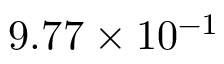Convert formula to latex. <formula><loc_0><loc_0><loc_500><loc_500>9 . 7 7 \times 1 0 ^ { - 1 }</formula> 